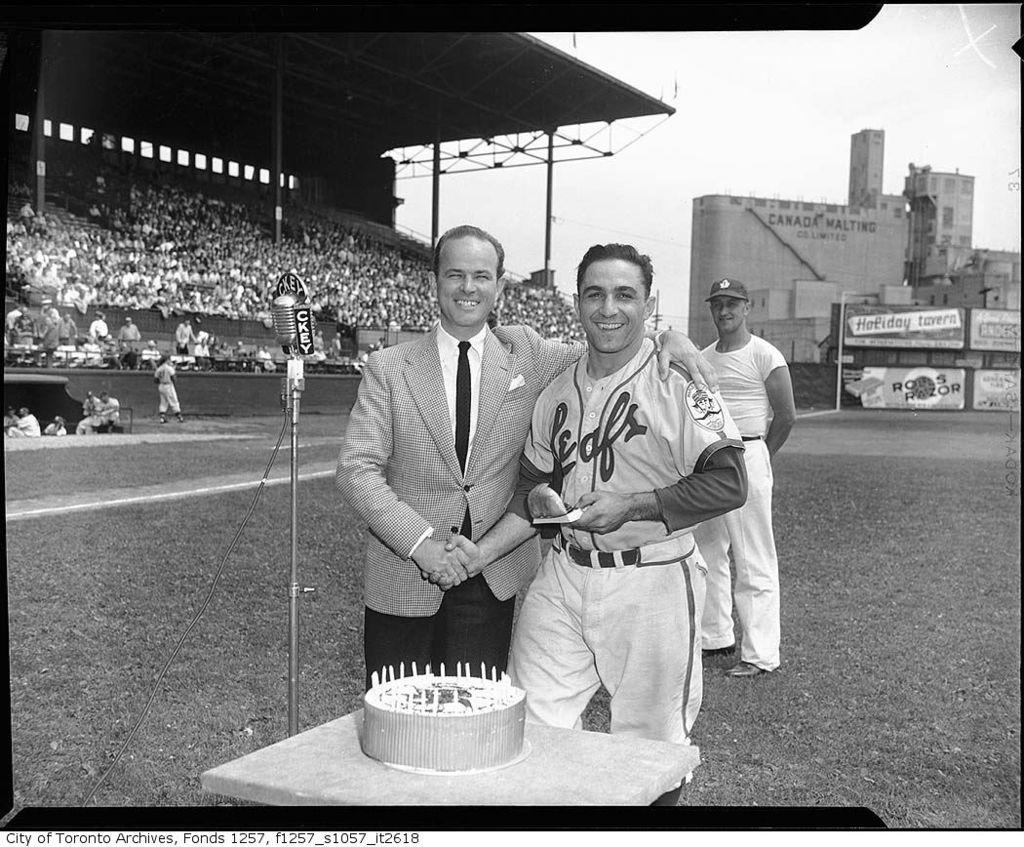<image>
Write a terse but informative summary of the picture. A Leafs player celebrates in front of a cake on a baseball field. 